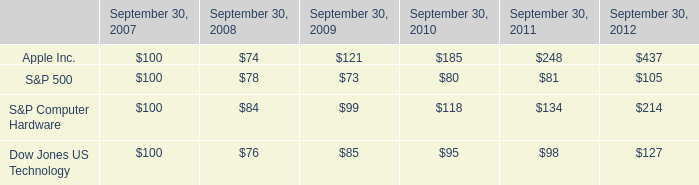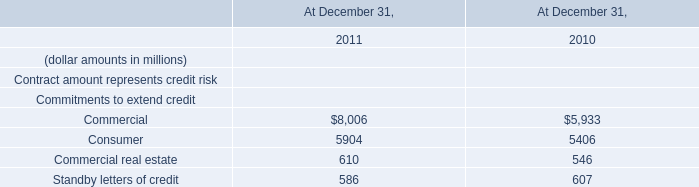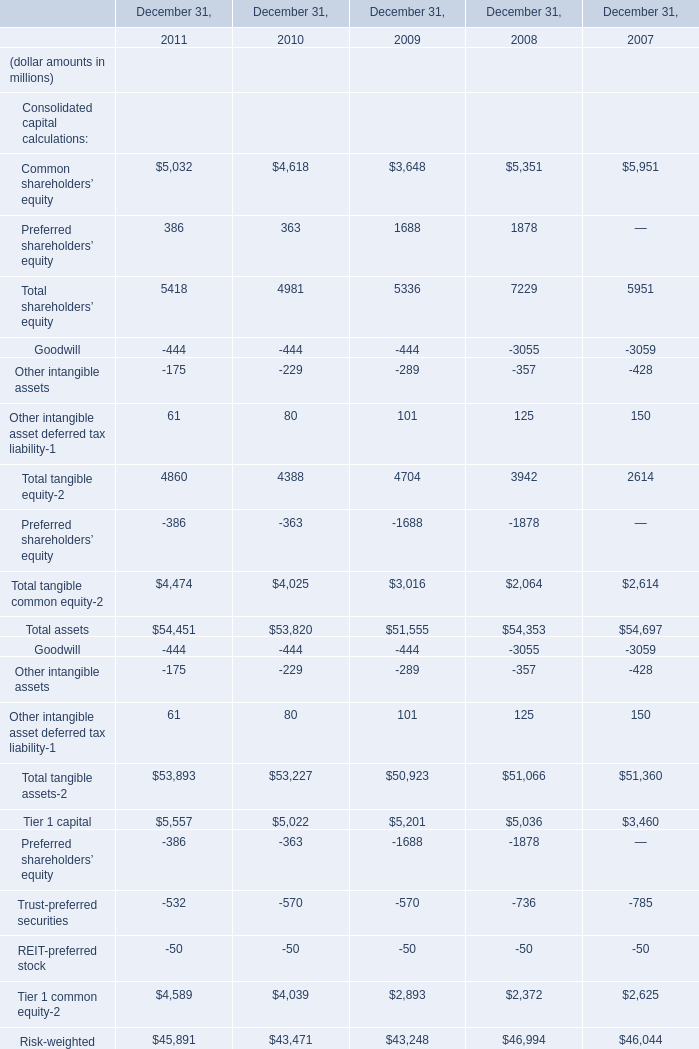What's the average of Commercial of At December 31, 2011, and Tier 1 capital of December 31, 2010 ? 
Computations: ((8006.0 + 5022.0) / 2)
Answer: 6514.0. 